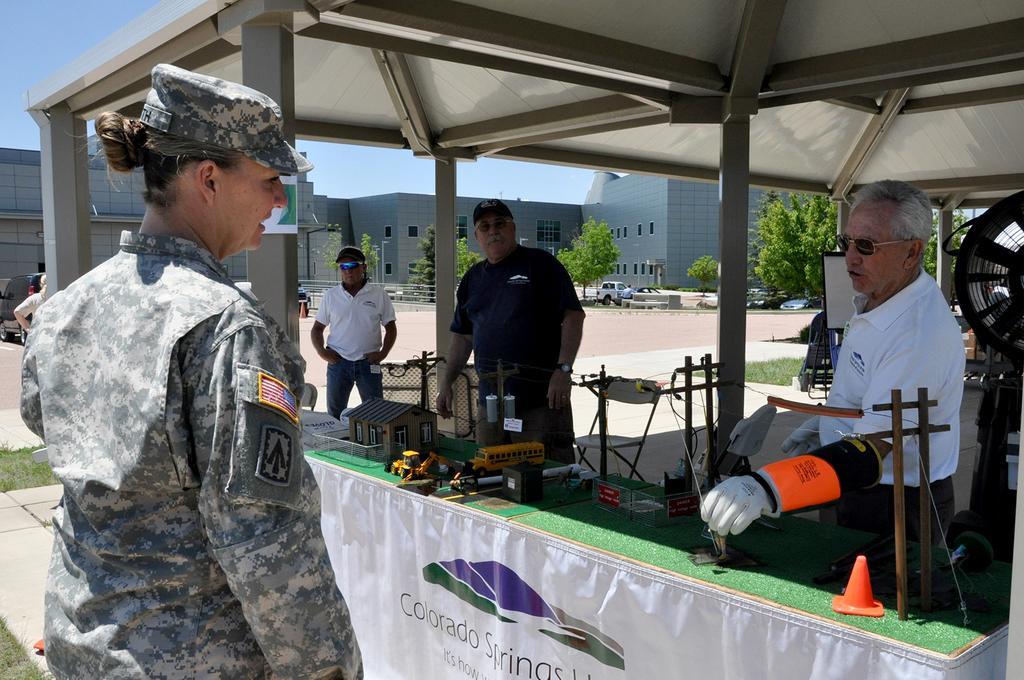Can you describe this image briefly? In this picture we can see there are some people standing and in front of the people there is a table and on the table there is a toy house, cone barrier and other objects and in front of the table there is a banner. Behind the people there are some objects, some vehicles parked on the path, trees, buildings and a sky. 